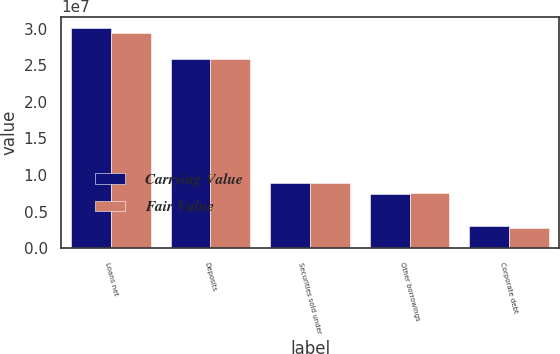<chart> <loc_0><loc_0><loc_500><loc_500><stacked_bar_chart><ecel><fcel>Loans net<fcel>Deposits<fcel>Securities sold under<fcel>Other borrowings<fcel>Corporate debt<nl><fcel>Carrying Value<fcel>3.01394e+07<fcel>2.58848e+07<fcel>8.93269e+06<fcel>7.4465e+06<fcel>3.0027e+06<nl><fcel>Fair Value<fcel>2.94157e+07<fcel>2.58647e+07<fcel>8.93765e+06<fcel>7.49595e+06<fcel>2.80076e+06<nl></chart> 